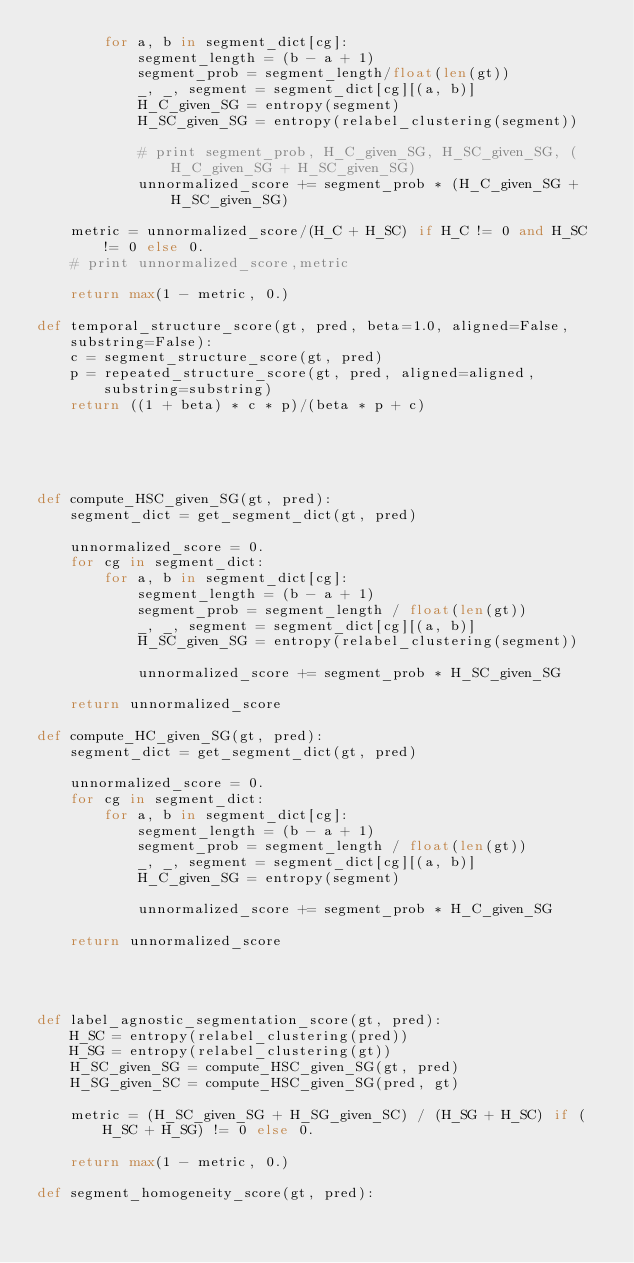Convert code to text. <code><loc_0><loc_0><loc_500><loc_500><_Python_>        for a, b in segment_dict[cg]:
            segment_length = (b - a + 1)
            segment_prob = segment_length/float(len(gt))
            _, _, segment = segment_dict[cg][(a, b)]
            H_C_given_SG = entropy(segment)
            H_SC_given_SG = entropy(relabel_clustering(segment))

            # print segment_prob, H_C_given_SG, H_SC_given_SG, (H_C_given_SG + H_SC_given_SG)
            unnormalized_score += segment_prob * (H_C_given_SG + H_SC_given_SG)

    metric = unnormalized_score/(H_C + H_SC) if H_C != 0 and H_SC != 0 else 0.
    # print unnormalized_score,metric

    return max(1 - metric, 0.)

def temporal_structure_score(gt, pred, beta=1.0, aligned=False, substring=False):
    c = segment_structure_score(gt, pred)
    p = repeated_structure_score(gt, pred, aligned=aligned, substring=substring)
    return ((1 + beta) * c * p)/(beta * p + c)





def compute_HSC_given_SG(gt, pred):
    segment_dict = get_segment_dict(gt, pred)

    unnormalized_score = 0.
    for cg in segment_dict:
        for a, b in segment_dict[cg]:
            segment_length = (b - a + 1)
            segment_prob = segment_length / float(len(gt))
            _, _, segment = segment_dict[cg][(a, b)]
            H_SC_given_SG = entropy(relabel_clustering(segment))

            unnormalized_score += segment_prob * H_SC_given_SG

    return unnormalized_score

def compute_HC_given_SG(gt, pred):
    segment_dict = get_segment_dict(gt, pred)

    unnormalized_score = 0.
    for cg in segment_dict:
        for a, b in segment_dict[cg]:
            segment_length = (b - a + 1)
            segment_prob = segment_length / float(len(gt))
            _, _, segment = segment_dict[cg][(a, b)]
            H_C_given_SG = entropy(segment)

            unnormalized_score += segment_prob * H_C_given_SG

    return unnormalized_score




def label_agnostic_segmentation_score(gt, pred):
    H_SC = entropy(relabel_clustering(pred))
    H_SG = entropy(relabel_clustering(gt))
    H_SC_given_SG = compute_HSC_given_SG(gt, pred)
    H_SG_given_SC = compute_HSC_given_SG(pred, gt)

    metric = (H_SC_given_SG + H_SG_given_SC) / (H_SG + H_SC) if (H_SC + H_SG) != 0 else 0.

    return max(1 - metric, 0.)

def segment_homogeneity_score(gt, pred):</code> 